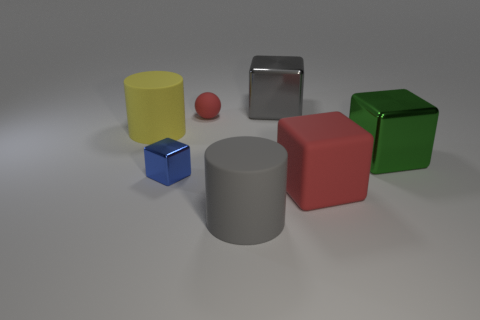Are there any other things of the same color as the small matte object?
Offer a very short reply. Yes. There is a large thing that is on the left side of the big gray cube and behind the big gray matte object; what is its shape?
Your answer should be compact. Cylinder. The big gray object in front of the rubber cylinder behind the blue shiny thing is what shape?
Your answer should be compact. Cylinder. Do the yellow object and the gray rubber object have the same shape?
Provide a succinct answer. Yes. There is a sphere that is the same color as the matte block; what material is it?
Offer a terse response. Rubber. Is the color of the rubber cube the same as the tiny rubber sphere?
Provide a succinct answer. Yes. How many large matte cylinders are to the right of the rubber thing behind the large yellow rubber cylinder to the left of the gray matte object?
Your response must be concise. 1. There is a big red object that is made of the same material as the large yellow object; what shape is it?
Offer a very short reply. Cube. There is a cylinder on the right side of the big cylinder behind the matte cylinder in front of the big green cube; what is its material?
Offer a terse response. Rubber. How many objects are things on the left side of the tiny metal object or gray metal objects?
Your answer should be compact. 2. 